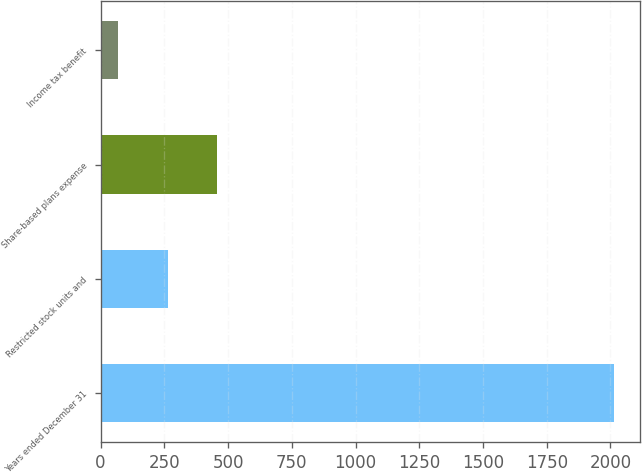Convert chart to OTSL. <chart><loc_0><loc_0><loc_500><loc_500><bar_chart><fcel>Years ended December 31<fcel>Restricted stock units and<fcel>Share-based plans expense<fcel>Income tax benefit<nl><fcel>2015<fcel>262.7<fcel>457.4<fcel>68<nl></chart> 